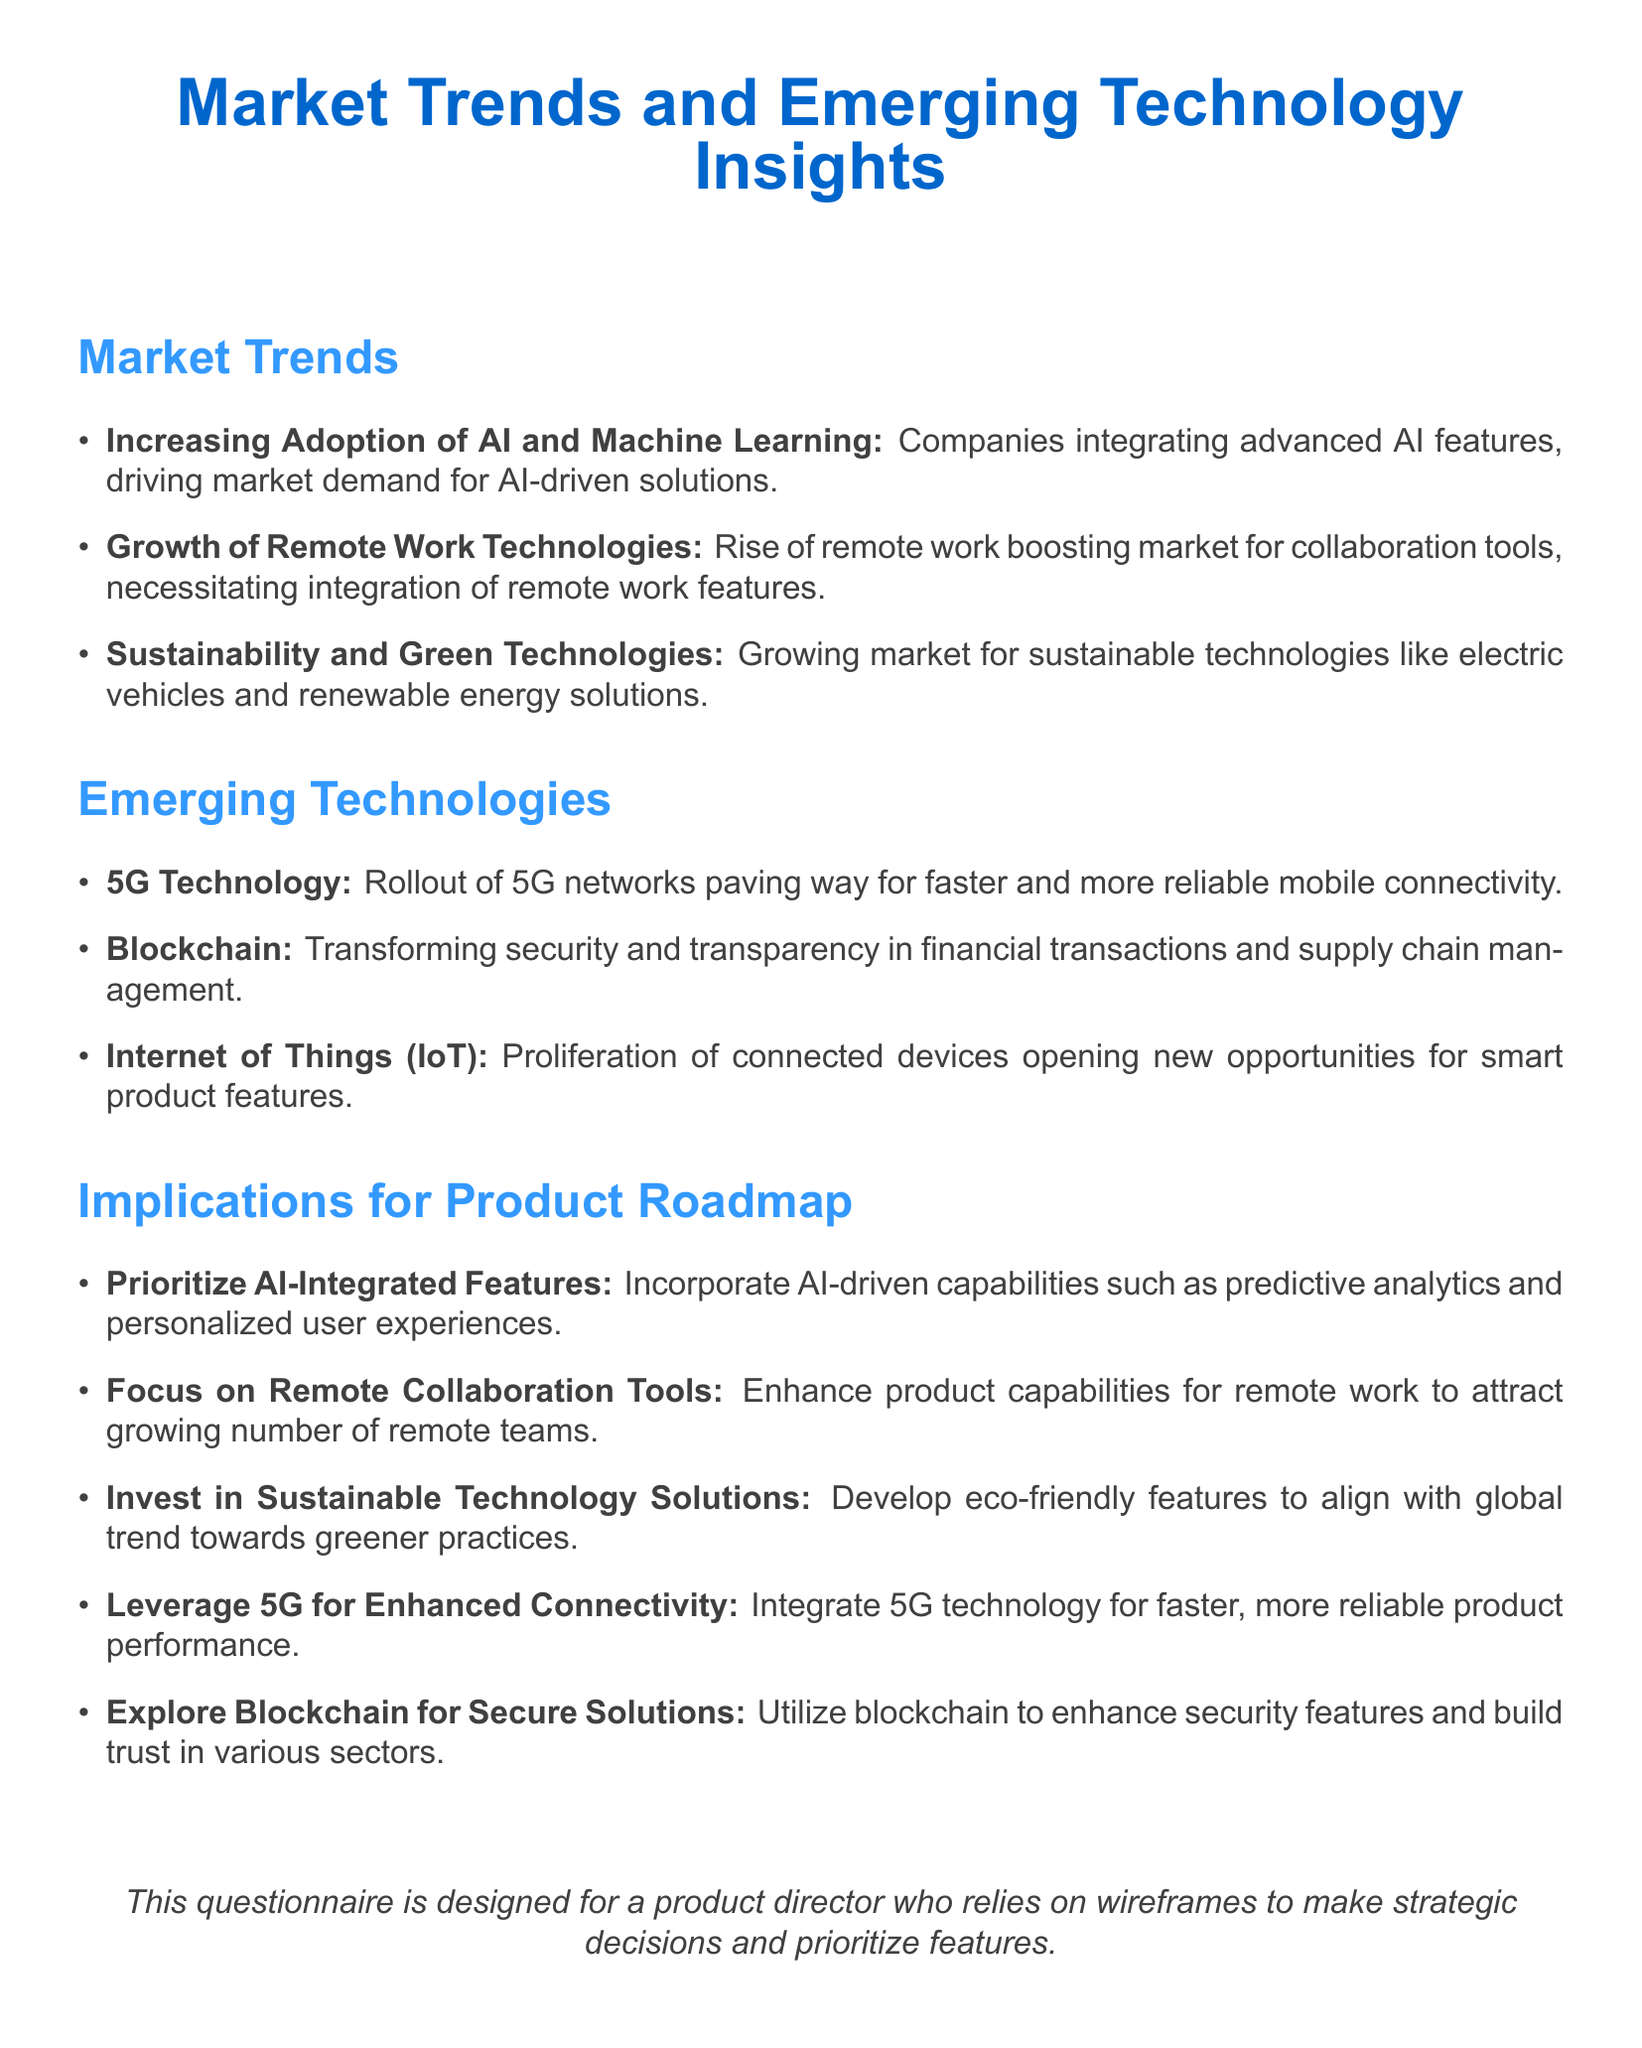What is the main technology driving market demand for solutions? The document states that advanced AI features are driving market demand for AI-driven solutions.
Answer: AI and Machine Learning What technology is mentioned that enhances security in transactions? Blockchain is highlighted in the document as transforming security and transparency in financial transactions.
Answer: Blockchain What growing market is linked to the trend in remote work? The document indicates that the rise of remote work is boosting the market for collaboration tools.
Answer: Collaboration tools Which emerging technology is associated with faster mobile connectivity? The document notes that the rollout of 5G networks is paving the way for faster and more reliable mobile connectivity.
Answer: 5G Technology How should products adapt to the trend of remote work? The implications suggest focusing on enhancing product capabilities for remote work.
Answer: Enhance remote work features What type of solutions should be developed to align with greener practices? The document emphasizes investing in sustainable technology solutions in line with global trends.
Answer: Eco-friendly features What AI capabilities should be prioritized in product development? The document advises incorporating AI-driven capabilities such as predictive analytics and personalized user experiences.
Answer: Predictive analytics What technology is expected to leverage enhanced connectivity? The document recommends integrating 5G technology for enhanced product performance.
Answer: 5G Technology What is suggested for increasing trust in various sectors? The document suggests utilizing blockchain to enhance security features and build trust.
Answer: Blockchain 